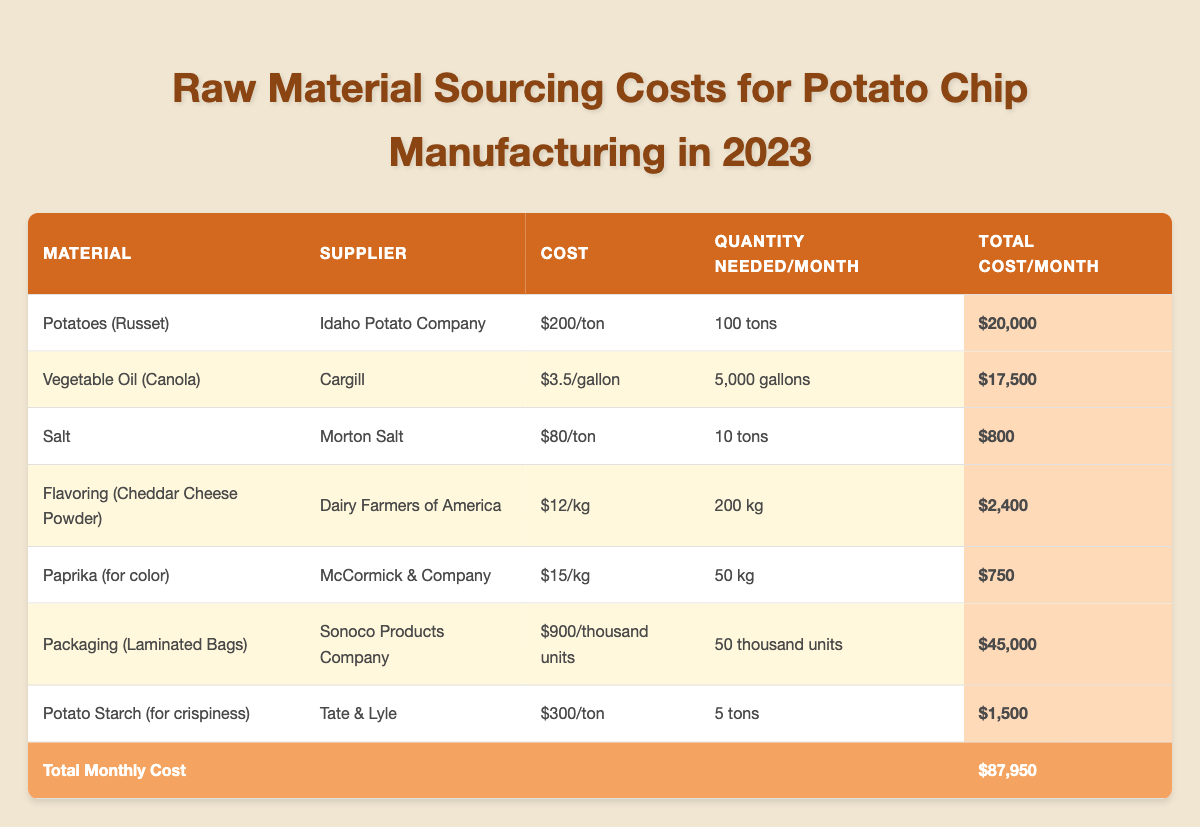What is the total monthly cost for sourcing raw materials? To find the total monthly cost, look at the last row of the table which sums all the individual total costs per month for each material. The total is $87,950.
Answer: $87,950 Which supplier provides the cheapest raw material? The cheapest raw material is Salt from Morton Salt, costing $80 per ton, which is less than the costs of other materials listed.
Answer: Morton Salt How much do we spend on Packaging per month? The monthly cost for Packaging (Laminated Bags) is specifically mentioned in the table as $45,000.
Answer: $45,000 What is the cost per ton of Potato Starch? The cost per ton for Potato Starch is noted in the table as $300.
Answer: $300 If we needed double the quantities of all materials listed, what would be the new total monthly cost? Doubling the total monthly cost of $87,950 gives us a new total of $175,900 (because $87,950 * 2 = $175,900).
Answer: $175,900 What is the quantity needed per month for Vegetable Oil? The quantity needed per month for Vegetable Oil (Canola) is shown in the table as 5,000 gallons.
Answer: 5,000 gallons Is the total monthly cost of Flavoring (Cheddar Cheese Powder) more than $3,000? The total monthly cost for Flavoring (Cheddar Cheese Powder) is $2,400, which is less than $3,000, making the statement false.
Answer: No Which raw material has the highest total monthly cost? Examining the total cost per month for each raw material, Packaging (Laminated Bags) has the highest total cost at $45,000.
Answer: Packaging (Laminated Bags) What is the combined cost of Potatoes and Vegetable Oil? The combined cost of Potatoes ($20,000) and Vegetable Oil ($17,500) is $37,500 ($20,000 + $17,500 = $37,500).
Answer: $37,500 How many kilograms of Flavoring are needed each month? The quantity needed per month for Flavoring (Cheddar Cheese Powder) is specified in the table as 200 kilograms.
Answer: 200 kg What percentage of the total monthly cost does salt represent? The cost of salt is $800. To find the percentage, divide $800 by the total $87,950 and multiply by 100, giving approximately 0.91%. So, salt represents about 0.91% of the total cost.
Answer: 0.91% 